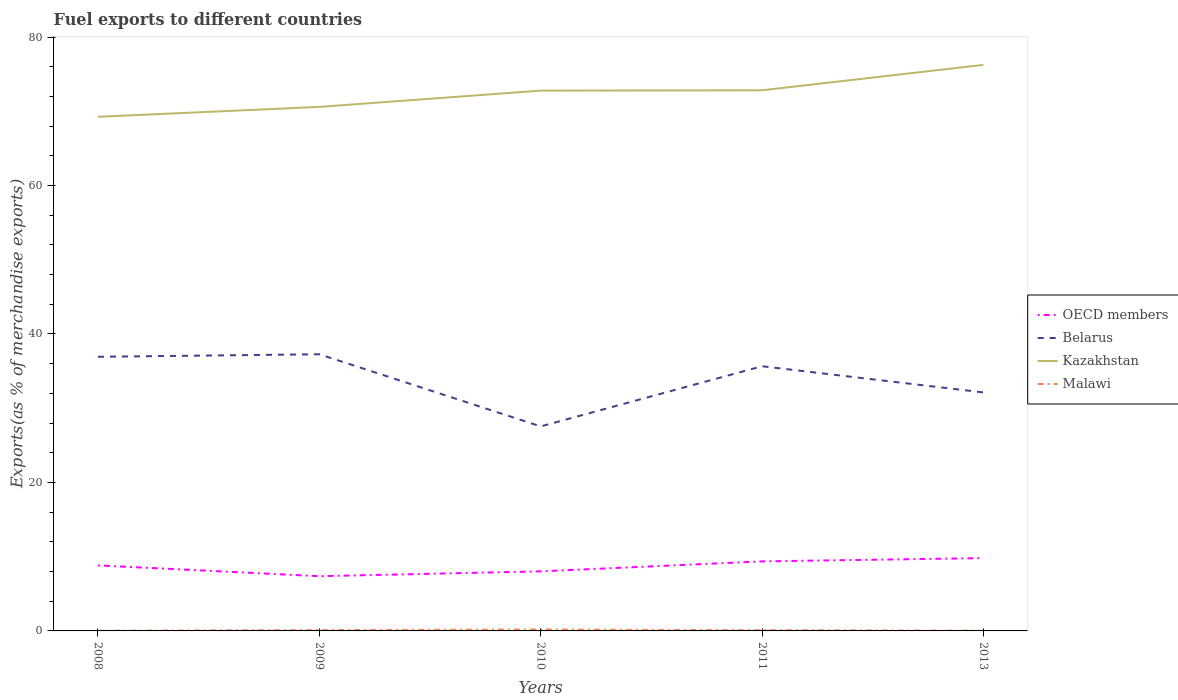How many different coloured lines are there?
Offer a very short reply. 4. Is the number of lines equal to the number of legend labels?
Provide a short and direct response. Yes. Across all years, what is the maximum percentage of exports to different countries in OECD members?
Your response must be concise. 7.37. What is the total percentage of exports to different countries in OECD members in the graph?
Your response must be concise. -1.99. What is the difference between the highest and the second highest percentage of exports to different countries in Belarus?
Provide a short and direct response. 9.72. What is the difference between the highest and the lowest percentage of exports to different countries in Malawi?
Ensure brevity in your answer.  3. How many lines are there?
Your answer should be very brief. 4. Are the values on the major ticks of Y-axis written in scientific E-notation?
Keep it short and to the point. No. Does the graph contain any zero values?
Offer a terse response. No. Where does the legend appear in the graph?
Your response must be concise. Center right. How many legend labels are there?
Provide a succinct answer. 4. What is the title of the graph?
Provide a short and direct response. Fuel exports to different countries. What is the label or title of the X-axis?
Offer a terse response. Years. What is the label or title of the Y-axis?
Provide a short and direct response. Exports(as % of merchandise exports). What is the Exports(as % of merchandise exports) of OECD members in 2008?
Give a very brief answer. 8.83. What is the Exports(as % of merchandise exports) in Belarus in 2008?
Your response must be concise. 36.93. What is the Exports(as % of merchandise exports) of Kazakhstan in 2008?
Your response must be concise. 69.25. What is the Exports(as % of merchandise exports) of Malawi in 2008?
Ensure brevity in your answer.  0.03. What is the Exports(as % of merchandise exports) in OECD members in 2009?
Your response must be concise. 7.37. What is the Exports(as % of merchandise exports) of Belarus in 2009?
Provide a succinct answer. 37.27. What is the Exports(as % of merchandise exports) in Kazakhstan in 2009?
Provide a succinct answer. 70.59. What is the Exports(as % of merchandise exports) of Malawi in 2009?
Keep it short and to the point. 0.11. What is the Exports(as % of merchandise exports) of OECD members in 2010?
Make the answer very short. 8.02. What is the Exports(as % of merchandise exports) of Belarus in 2010?
Offer a very short reply. 27.55. What is the Exports(as % of merchandise exports) of Kazakhstan in 2010?
Give a very brief answer. 72.78. What is the Exports(as % of merchandise exports) of Malawi in 2010?
Your answer should be compact. 0.19. What is the Exports(as % of merchandise exports) of OECD members in 2011?
Your answer should be compact. 9.37. What is the Exports(as % of merchandise exports) in Belarus in 2011?
Keep it short and to the point. 35.65. What is the Exports(as % of merchandise exports) of Kazakhstan in 2011?
Give a very brief answer. 72.83. What is the Exports(as % of merchandise exports) of Malawi in 2011?
Your answer should be very brief. 0.1. What is the Exports(as % of merchandise exports) of OECD members in 2013?
Keep it short and to the point. 9.81. What is the Exports(as % of merchandise exports) in Belarus in 2013?
Your response must be concise. 32.13. What is the Exports(as % of merchandise exports) of Kazakhstan in 2013?
Your answer should be very brief. 76.25. What is the Exports(as % of merchandise exports) in Malawi in 2013?
Keep it short and to the point. 0.04. Across all years, what is the maximum Exports(as % of merchandise exports) in OECD members?
Keep it short and to the point. 9.81. Across all years, what is the maximum Exports(as % of merchandise exports) in Belarus?
Your answer should be compact. 37.27. Across all years, what is the maximum Exports(as % of merchandise exports) of Kazakhstan?
Your answer should be very brief. 76.25. Across all years, what is the maximum Exports(as % of merchandise exports) of Malawi?
Offer a very short reply. 0.19. Across all years, what is the minimum Exports(as % of merchandise exports) of OECD members?
Your answer should be compact. 7.37. Across all years, what is the minimum Exports(as % of merchandise exports) of Belarus?
Your answer should be very brief. 27.55. Across all years, what is the minimum Exports(as % of merchandise exports) in Kazakhstan?
Provide a succinct answer. 69.25. Across all years, what is the minimum Exports(as % of merchandise exports) in Malawi?
Provide a short and direct response. 0.03. What is the total Exports(as % of merchandise exports) of OECD members in the graph?
Offer a terse response. 43.4. What is the total Exports(as % of merchandise exports) in Belarus in the graph?
Your response must be concise. 169.52. What is the total Exports(as % of merchandise exports) of Kazakhstan in the graph?
Your response must be concise. 361.69. What is the total Exports(as % of merchandise exports) in Malawi in the graph?
Keep it short and to the point. 0.46. What is the difference between the Exports(as % of merchandise exports) in OECD members in 2008 and that in 2009?
Offer a terse response. 1.46. What is the difference between the Exports(as % of merchandise exports) in Belarus in 2008 and that in 2009?
Your answer should be compact. -0.34. What is the difference between the Exports(as % of merchandise exports) in Kazakhstan in 2008 and that in 2009?
Your answer should be very brief. -1.33. What is the difference between the Exports(as % of merchandise exports) in Malawi in 2008 and that in 2009?
Offer a terse response. -0.09. What is the difference between the Exports(as % of merchandise exports) of OECD members in 2008 and that in 2010?
Give a very brief answer. 0.8. What is the difference between the Exports(as % of merchandise exports) of Belarus in 2008 and that in 2010?
Offer a very short reply. 9.38. What is the difference between the Exports(as % of merchandise exports) in Kazakhstan in 2008 and that in 2010?
Your response must be concise. -3.52. What is the difference between the Exports(as % of merchandise exports) in Malawi in 2008 and that in 2010?
Offer a very short reply. -0.16. What is the difference between the Exports(as % of merchandise exports) of OECD members in 2008 and that in 2011?
Provide a short and direct response. -0.54. What is the difference between the Exports(as % of merchandise exports) in Belarus in 2008 and that in 2011?
Offer a terse response. 1.27. What is the difference between the Exports(as % of merchandise exports) in Kazakhstan in 2008 and that in 2011?
Make the answer very short. -3.57. What is the difference between the Exports(as % of merchandise exports) of Malawi in 2008 and that in 2011?
Your answer should be compact. -0.07. What is the difference between the Exports(as % of merchandise exports) of OECD members in 2008 and that in 2013?
Offer a very short reply. -0.98. What is the difference between the Exports(as % of merchandise exports) in Belarus in 2008 and that in 2013?
Provide a succinct answer. 4.8. What is the difference between the Exports(as % of merchandise exports) in Kazakhstan in 2008 and that in 2013?
Make the answer very short. -6.99. What is the difference between the Exports(as % of merchandise exports) of Malawi in 2008 and that in 2013?
Offer a very short reply. -0.01. What is the difference between the Exports(as % of merchandise exports) of OECD members in 2009 and that in 2010?
Your answer should be very brief. -0.65. What is the difference between the Exports(as % of merchandise exports) of Belarus in 2009 and that in 2010?
Keep it short and to the point. 9.72. What is the difference between the Exports(as % of merchandise exports) in Kazakhstan in 2009 and that in 2010?
Your response must be concise. -2.19. What is the difference between the Exports(as % of merchandise exports) in Malawi in 2009 and that in 2010?
Ensure brevity in your answer.  -0.07. What is the difference between the Exports(as % of merchandise exports) of OECD members in 2009 and that in 2011?
Ensure brevity in your answer.  -1.99. What is the difference between the Exports(as % of merchandise exports) in Belarus in 2009 and that in 2011?
Offer a terse response. 1.61. What is the difference between the Exports(as % of merchandise exports) in Kazakhstan in 2009 and that in 2011?
Provide a succinct answer. -2.24. What is the difference between the Exports(as % of merchandise exports) in Malawi in 2009 and that in 2011?
Your answer should be very brief. 0.02. What is the difference between the Exports(as % of merchandise exports) of OECD members in 2009 and that in 2013?
Provide a succinct answer. -2.44. What is the difference between the Exports(as % of merchandise exports) in Belarus in 2009 and that in 2013?
Offer a very short reply. 5.14. What is the difference between the Exports(as % of merchandise exports) in Kazakhstan in 2009 and that in 2013?
Keep it short and to the point. -5.66. What is the difference between the Exports(as % of merchandise exports) in Malawi in 2009 and that in 2013?
Provide a succinct answer. 0.08. What is the difference between the Exports(as % of merchandise exports) in OECD members in 2010 and that in 2011?
Provide a short and direct response. -1.34. What is the difference between the Exports(as % of merchandise exports) in Belarus in 2010 and that in 2011?
Offer a very short reply. -8.1. What is the difference between the Exports(as % of merchandise exports) in Kazakhstan in 2010 and that in 2011?
Give a very brief answer. -0.05. What is the difference between the Exports(as % of merchandise exports) of Malawi in 2010 and that in 2011?
Offer a terse response. 0.09. What is the difference between the Exports(as % of merchandise exports) of OECD members in 2010 and that in 2013?
Offer a very short reply. -1.78. What is the difference between the Exports(as % of merchandise exports) in Belarus in 2010 and that in 2013?
Keep it short and to the point. -4.58. What is the difference between the Exports(as % of merchandise exports) of Kazakhstan in 2010 and that in 2013?
Provide a succinct answer. -3.47. What is the difference between the Exports(as % of merchandise exports) in Malawi in 2010 and that in 2013?
Give a very brief answer. 0.15. What is the difference between the Exports(as % of merchandise exports) in OECD members in 2011 and that in 2013?
Keep it short and to the point. -0.44. What is the difference between the Exports(as % of merchandise exports) of Belarus in 2011 and that in 2013?
Give a very brief answer. 3.53. What is the difference between the Exports(as % of merchandise exports) of Kazakhstan in 2011 and that in 2013?
Offer a terse response. -3.42. What is the difference between the Exports(as % of merchandise exports) in Malawi in 2011 and that in 2013?
Keep it short and to the point. 0.06. What is the difference between the Exports(as % of merchandise exports) of OECD members in 2008 and the Exports(as % of merchandise exports) of Belarus in 2009?
Offer a terse response. -28.44. What is the difference between the Exports(as % of merchandise exports) in OECD members in 2008 and the Exports(as % of merchandise exports) in Kazakhstan in 2009?
Make the answer very short. -61.76. What is the difference between the Exports(as % of merchandise exports) of OECD members in 2008 and the Exports(as % of merchandise exports) of Malawi in 2009?
Make the answer very short. 8.71. What is the difference between the Exports(as % of merchandise exports) of Belarus in 2008 and the Exports(as % of merchandise exports) of Kazakhstan in 2009?
Your answer should be compact. -33.66. What is the difference between the Exports(as % of merchandise exports) of Belarus in 2008 and the Exports(as % of merchandise exports) of Malawi in 2009?
Offer a terse response. 36.81. What is the difference between the Exports(as % of merchandise exports) of Kazakhstan in 2008 and the Exports(as % of merchandise exports) of Malawi in 2009?
Provide a short and direct response. 69.14. What is the difference between the Exports(as % of merchandise exports) in OECD members in 2008 and the Exports(as % of merchandise exports) in Belarus in 2010?
Your answer should be very brief. -18.72. What is the difference between the Exports(as % of merchandise exports) in OECD members in 2008 and the Exports(as % of merchandise exports) in Kazakhstan in 2010?
Ensure brevity in your answer.  -63.95. What is the difference between the Exports(as % of merchandise exports) of OECD members in 2008 and the Exports(as % of merchandise exports) of Malawi in 2010?
Keep it short and to the point. 8.64. What is the difference between the Exports(as % of merchandise exports) of Belarus in 2008 and the Exports(as % of merchandise exports) of Kazakhstan in 2010?
Make the answer very short. -35.85. What is the difference between the Exports(as % of merchandise exports) of Belarus in 2008 and the Exports(as % of merchandise exports) of Malawi in 2010?
Offer a terse response. 36.74. What is the difference between the Exports(as % of merchandise exports) in Kazakhstan in 2008 and the Exports(as % of merchandise exports) in Malawi in 2010?
Your answer should be very brief. 69.07. What is the difference between the Exports(as % of merchandise exports) of OECD members in 2008 and the Exports(as % of merchandise exports) of Belarus in 2011?
Keep it short and to the point. -26.83. What is the difference between the Exports(as % of merchandise exports) of OECD members in 2008 and the Exports(as % of merchandise exports) of Kazakhstan in 2011?
Provide a short and direct response. -64. What is the difference between the Exports(as % of merchandise exports) in OECD members in 2008 and the Exports(as % of merchandise exports) in Malawi in 2011?
Ensure brevity in your answer.  8.73. What is the difference between the Exports(as % of merchandise exports) of Belarus in 2008 and the Exports(as % of merchandise exports) of Kazakhstan in 2011?
Your response must be concise. -35.9. What is the difference between the Exports(as % of merchandise exports) of Belarus in 2008 and the Exports(as % of merchandise exports) of Malawi in 2011?
Your response must be concise. 36.83. What is the difference between the Exports(as % of merchandise exports) of Kazakhstan in 2008 and the Exports(as % of merchandise exports) of Malawi in 2011?
Provide a short and direct response. 69.16. What is the difference between the Exports(as % of merchandise exports) in OECD members in 2008 and the Exports(as % of merchandise exports) in Belarus in 2013?
Offer a very short reply. -23.3. What is the difference between the Exports(as % of merchandise exports) in OECD members in 2008 and the Exports(as % of merchandise exports) in Kazakhstan in 2013?
Make the answer very short. -67.42. What is the difference between the Exports(as % of merchandise exports) in OECD members in 2008 and the Exports(as % of merchandise exports) in Malawi in 2013?
Give a very brief answer. 8.79. What is the difference between the Exports(as % of merchandise exports) of Belarus in 2008 and the Exports(as % of merchandise exports) of Kazakhstan in 2013?
Offer a terse response. -39.32. What is the difference between the Exports(as % of merchandise exports) in Belarus in 2008 and the Exports(as % of merchandise exports) in Malawi in 2013?
Provide a short and direct response. 36.89. What is the difference between the Exports(as % of merchandise exports) in Kazakhstan in 2008 and the Exports(as % of merchandise exports) in Malawi in 2013?
Provide a succinct answer. 69.22. What is the difference between the Exports(as % of merchandise exports) of OECD members in 2009 and the Exports(as % of merchandise exports) of Belarus in 2010?
Offer a terse response. -20.18. What is the difference between the Exports(as % of merchandise exports) of OECD members in 2009 and the Exports(as % of merchandise exports) of Kazakhstan in 2010?
Give a very brief answer. -65.41. What is the difference between the Exports(as % of merchandise exports) in OECD members in 2009 and the Exports(as % of merchandise exports) in Malawi in 2010?
Provide a short and direct response. 7.19. What is the difference between the Exports(as % of merchandise exports) in Belarus in 2009 and the Exports(as % of merchandise exports) in Kazakhstan in 2010?
Offer a terse response. -35.51. What is the difference between the Exports(as % of merchandise exports) of Belarus in 2009 and the Exports(as % of merchandise exports) of Malawi in 2010?
Keep it short and to the point. 37.08. What is the difference between the Exports(as % of merchandise exports) of Kazakhstan in 2009 and the Exports(as % of merchandise exports) of Malawi in 2010?
Provide a short and direct response. 70.4. What is the difference between the Exports(as % of merchandise exports) in OECD members in 2009 and the Exports(as % of merchandise exports) in Belarus in 2011?
Ensure brevity in your answer.  -28.28. What is the difference between the Exports(as % of merchandise exports) in OECD members in 2009 and the Exports(as % of merchandise exports) in Kazakhstan in 2011?
Provide a succinct answer. -65.45. What is the difference between the Exports(as % of merchandise exports) of OECD members in 2009 and the Exports(as % of merchandise exports) of Malawi in 2011?
Your answer should be compact. 7.27. What is the difference between the Exports(as % of merchandise exports) of Belarus in 2009 and the Exports(as % of merchandise exports) of Kazakhstan in 2011?
Your response must be concise. -35.56. What is the difference between the Exports(as % of merchandise exports) in Belarus in 2009 and the Exports(as % of merchandise exports) in Malawi in 2011?
Your answer should be very brief. 37.17. What is the difference between the Exports(as % of merchandise exports) of Kazakhstan in 2009 and the Exports(as % of merchandise exports) of Malawi in 2011?
Your response must be concise. 70.49. What is the difference between the Exports(as % of merchandise exports) of OECD members in 2009 and the Exports(as % of merchandise exports) of Belarus in 2013?
Provide a succinct answer. -24.75. What is the difference between the Exports(as % of merchandise exports) in OECD members in 2009 and the Exports(as % of merchandise exports) in Kazakhstan in 2013?
Provide a short and direct response. -68.88. What is the difference between the Exports(as % of merchandise exports) of OECD members in 2009 and the Exports(as % of merchandise exports) of Malawi in 2013?
Provide a short and direct response. 7.34. What is the difference between the Exports(as % of merchandise exports) in Belarus in 2009 and the Exports(as % of merchandise exports) in Kazakhstan in 2013?
Your answer should be very brief. -38.98. What is the difference between the Exports(as % of merchandise exports) of Belarus in 2009 and the Exports(as % of merchandise exports) of Malawi in 2013?
Provide a succinct answer. 37.23. What is the difference between the Exports(as % of merchandise exports) of Kazakhstan in 2009 and the Exports(as % of merchandise exports) of Malawi in 2013?
Your answer should be very brief. 70.55. What is the difference between the Exports(as % of merchandise exports) in OECD members in 2010 and the Exports(as % of merchandise exports) in Belarus in 2011?
Give a very brief answer. -27.63. What is the difference between the Exports(as % of merchandise exports) in OECD members in 2010 and the Exports(as % of merchandise exports) in Kazakhstan in 2011?
Give a very brief answer. -64.8. What is the difference between the Exports(as % of merchandise exports) of OECD members in 2010 and the Exports(as % of merchandise exports) of Malawi in 2011?
Provide a short and direct response. 7.93. What is the difference between the Exports(as % of merchandise exports) in Belarus in 2010 and the Exports(as % of merchandise exports) in Kazakhstan in 2011?
Your response must be concise. -45.28. What is the difference between the Exports(as % of merchandise exports) in Belarus in 2010 and the Exports(as % of merchandise exports) in Malawi in 2011?
Your response must be concise. 27.45. What is the difference between the Exports(as % of merchandise exports) of Kazakhstan in 2010 and the Exports(as % of merchandise exports) of Malawi in 2011?
Make the answer very short. 72.68. What is the difference between the Exports(as % of merchandise exports) of OECD members in 2010 and the Exports(as % of merchandise exports) of Belarus in 2013?
Your answer should be very brief. -24.1. What is the difference between the Exports(as % of merchandise exports) in OECD members in 2010 and the Exports(as % of merchandise exports) in Kazakhstan in 2013?
Provide a short and direct response. -68.22. What is the difference between the Exports(as % of merchandise exports) in OECD members in 2010 and the Exports(as % of merchandise exports) in Malawi in 2013?
Keep it short and to the point. 7.99. What is the difference between the Exports(as % of merchandise exports) in Belarus in 2010 and the Exports(as % of merchandise exports) in Kazakhstan in 2013?
Keep it short and to the point. -48.7. What is the difference between the Exports(as % of merchandise exports) in Belarus in 2010 and the Exports(as % of merchandise exports) in Malawi in 2013?
Your answer should be very brief. 27.51. What is the difference between the Exports(as % of merchandise exports) of Kazakhstan in 2010 and the Exports(as % of merchandise exports) of Malawi in 2013?
Your answer should be very brief. 72.74. What is the difference between the Exports(as % of merchandise exports) in OECD members in 2011 and the Exports(as % of merchandise exports) in Belarus in 2013?
Your answer should be compact. -22.76. What is the difference between the Exports(as % of merchandise exports) of OECD members in 2011 and the Exports(as % of merchandise exports) of Kazakhstan in 2013?
Your answer should be compact. -66.88. What is the difference between the Exports(as % of merchandise exports) of OECD members in 2011 and the Exports(as % of merchandise exports) of Malawi in 2013?
Your response must be concise. 9.33. What is the difference between the Exports(as % of merchandise exports) in Belarus in 2011 and the Exports(as % of merchandise exports) in Kazakhstan in 2013?
Offer a very short reply. -40.59. What is the difference between the Exports(as % of merchandise exports) of Belarus in 2011 and the Exports(as % of merchandise exports) of Malawi in 2013?
Provide a succinct answer. 35.62. What is the difference between the Exports(as % of merchandise exports) of Kazakhstan in 2011 and the Exports(as % of merchandise exports) of Malawi in 2013?
Provide a succinct answer. 72.79. What is the average Exports(as % of merchandise exports) of OECD members per year?
Provide a short and direct response. 8.68. What is the average Exports(as % of merchandise exports) in Belarus per year?
Provide a succinct answer. 33.9. What is the average Exports(as % of merchandise exports) in Kazakhstan per year?
Give a very brief answer. 72.34. What is the average Exports(as % of merchandise exports) of Malawi per year?
Ensure brevity in your answer.  0.09. In the year 2008, what is the difference between the Exports(as % of merchandise exports) in OECD members and Exports(as % of merchandise exports) in Belarus?
Offer a terse response. -28.1. In the year 2008, what is the difference between the Exports(as % of merchandise exports) in OECD members and Exports(as % of merchandise exports) in Kazakhstan?
Ensure brevity in your answer.  -60.43. In the year 2008, what is the difference between the Exports(as % of merchandise exports) in OECD members and Exports(as % of merchandise exports) in Malawi?
Make the answer very short. 8.8. In the year 2008, what is the difference between the Exports(as % of merchandise exports) of Belarus and Exports(as % of merchandise exports) of Kazakhstan?
Keep it short and to the point. -32.33. In the year 2008, what is the difference between the Exports(as % of merchandise exports) of Belarus and Exports(as % of merchandise exports) of Malawi?
Provide a short and direct response. 36.9. In the year 2008, what is the difference between the Exports(as % of merchandise exports) of Kazakhstan and Exports(as % of merchandise exports) of Malawi?
Your response must be concise. 69.23. In the year 2009, what is the difference between the Exports(as % of merchandise exports) of OECD members and Exports(as % of merchandise exports) of Belarus?
Provide a succinct answer. -29.89. In the year 2009, what is the difference between the Exports(as % of merchandise exports) of OECD members and Exports(as % of merchandise exports) of Kazakhstan?
Ensure brevity in your answer.  -63.21. In the year 2009, what is the difference between the Exports(as % of merchandise exports) of OECD members and Exports(as % of merchandise exports) of Malawi?
Ensure brevity in your answer.  7.26. In the year 2009, what is the difference between the Exports(as % of merchandise exports) in Belarus and Exports(as % of merchandise exports) in Kazakhstan?
Give a very brief answer. -33.32. In the year 2009, what is the difference between the Exports(as % of merchandise exports) of Belarus and Exports(as % of merchandise exports) of Malawi?
Keep it short and to the point. 37.15. In the year 2009, what is the difference between the Exports(as % of merchandise exports) in Kazakhstan and Exports(as % of merchandise exports) in Malawi?
Provide a short and direct response. 70.47. In the year 2010, what is the difference between the Exports(as % of merchandise exports) in OECD members and Exports(as % of merchandise exports) in Belarus?
Ensure brevity in your answer.  -19.52. In the year 2010, what is the difference between the Exports(as % of merchandise exports) of OECD members and Exports(as % of merchandise exports) of Kazakhstan?
Ensure brevity in your answer.  -64.75. In the year 2010, what is the difference between the Exports(as % of merchandise exports) of OECD members and Exports(as % of merchandise exports) of Malawi?
Ensure brevity in your answer.  7.84. In the year 2010, what is the difference between the Exports(as % of merchandise exports) in Belarus and Exports(as % of merchandise exports) in Kazakhstan?
Provide a short and direct response. -45.23. In the year 2010, what is the difference between the Exports(as % of merchandise exports) in Belarus and Exports(as % of merchandise exports) in Malawi?
Offer a terse response. 27.36. In the year 2010, what is the difference between the Exports(as % of merchandise exports) in Kazakhstan and Exports(as % of merchandise exports) in Malawi?
Provide a short and direct response. 72.59. In the year 2011, what is the difference between the Exports(as % of merchandise exports) of OECD members and Exports(as % of merchandise exports) of Belarus?
Make the answer very short. -26.29. In the year 2011, what is the difference between the Exports(as % of merchandise exports) in OECD members and Exports(as % of merchandise exports) in Kazakhstan?
Give a very brief answer. -63.46. In the year 2011, what is the difference between the Exports(as % of merchandise exports) of OECD members and Exports(as % of merchandise exports) of Malawi?
Provide a succinct answer. 9.27. In the year 2011, what is the difference between the Exports(as % of merchandise exports) of Belarus and Exports(as % of merchandise exports) of Kazakhstan?
Make the answer very short. -37.17. In the year 2011, what is the difference between the Exports(as % of merchandise exports) in Belarus and Exports(as % of merchandise exports) in Malawi?
Provide a succinct answer. 35.56. In the year 2011, what is the difference between the Exports(as % of merchandise exports) of Kazakhstan and Exports(as % of merchandise exports) of Malawi?
Provide a succinct answer. 72.73. In the year 2013, what is the difference between the Exports(as % of merchandise exports) of OECD members and Exports(as % of merchandise exports) of Belarus?
Offer a very short reply. -22.32. In the year 2013, what is the difference between the Exports(as % of merchandise exports) in OECD members and Exports(as % of merchandise exports) in Kazakhstan?
Give a very brief answer. -66.44. In the year 2013, what is the difference between the Exports(as % of merchandise exports) of OECD members and Exports(as % of merchandise exports) of Malawi?
Keep it short and to the point. 9.77. In the year 2013, what is the difference between the Exports(as % of merchandise exports) of Belarus and Exports(as % of merchandise exports) of Kazakhstan?
Give a very brief answer. -44.12. In the year 2013, what is the difference between the Exports(as % of merchandise exports) of Belarus and Exports(as % of merchandise exports) of Malawi?
Ensure brevity in your answer.  32.09. In the year 2013, what is the difference between the Exports(as % of merchandise exports) of Kazakhstan and Exports(as % of merchandise exports) of Malawi?
Offer a very short reply. 76.21. What is the ratio of the Exports(as % of merchandise exports) of OECD members in 2008 to that in 2009?
Provide a succinct answer. 1.2. What is the ratio of the Exports(as % of merchandise exports) in Belarus in 2008 to that in 2009?
Your answer should be very brief. 0.99. What is the ratio of the Exports(as % of merchandise exports) of Kazakhstan in 2008 to that in 2009?
Provide a short and direct response. 0.98. What is the ratio of the Exports(as % of merchandise exports) of Malawi in 2008 to that in 2009?
Ensure brevity in your answer.  0.24. What is the ratio of the Exports(as % of merchandise exports) of Belarus in 2008 to that in 2010?
Offer a terse response. 1.34. What is the ratio of the Exports(as % of merchandise exports) in Kazakhstan in 2008 to that in 2010?
Your response must be concise. 0.95. What is the ratio of the Exports(as % of merchandise exports) in Malawi in 2008 to that in 2010?
Your answer should be very brief. 0.15. What is the ratio of the Exports(as % of merchandise exports) in OECD members in 2008 to that in 2011?
Keep it short and to the point. 0.94. What is the ratio of the Exports(as % of merchandise exports) of Belarus in 2008 to that in 2011?
Your response must be concise. 1.04. What is the ratio of the Exports(as % of merchandise exports) in Kazakhstan in 2008 to that in 2011?
Offer a terse response. 0.95. What is the ratio of the Exports(as % of merchandise exports) in Malawi in 2008 to that in 2011?
Your answer should be compact. 0.27. What is the ratio of the Exports(as % of merchandise exports) of OECD members in 2008 to that in 2013?
Offer a terse response. 0.9. What is the ratio of the Exports(as % of merchandise exports) of Belarus in 2008 to that in 2013?
Offer a terse response. 1.15. What is the ratio of the Exports(as % of merchandise exports) of Kazakhstan in 2008 to that in 2013?
Offer a terse response. 0.91. What is the ratio of the Exports(as % of merchandise exports) in Malawi in 2008 to that in 2013?
Offer a very short reply. 0.74. What is the ratio of the Exports(as % of merchandise exports) in OECD members in 2009 to that in 2010?
Your response must be concise. 0.92. What is the ratio of the Exports(as % of merchandise exports) in Belarus in 2009 to that in 2010?
Your response must be concise. 1.35. What is the ratio of the Exports(as % of merchandise exports) of Kazakhstan in 2009 to that in 2010?
Your response must be concise. 0.97. What is the ratio of the Exports(as % of merchandise exports) of Malawi in 2009 to that in 2010?
Ensure brevity in your answer.  0.61. What is the ratio of the Exports(as % of merchandise exports) of OECD members in 2009 to that in 2011?
Offer a terse response. 0.79. What is the ratio of the Exports(as % of merchandise exports) in Belarus in 2009 to that in 2011?
Give a very brief answer. 1.05. What is the ratio of the Exports(as % of merchandise exports) in Kazakhstan in 2009 to that in 2011?
Give a very brief answer. 0.97. What is the ratio of the Exports(as % of merchandise exports) of Malawi in 2009 to that in 2011?
Offer a terse response. 1.15. What is the ratio of the Exports(as % of merchandise exports) of OECD members in 2009 to that in 2013?
Offer a very short reply. 0.75. What is the ratio of the Exports(as % of merchandise exports) in Belarus in 2009 to that in 2013?
Give a very brief answer. 1.16. What is the ratio of the Exports(as % of merchandise exports) of Kazakhstan in 2009 to that in 2013?
Your answer should be compact. 0.93. What is the ratio of the Exports(as % of merchandise exports) of Malawi in 2009 to that in 2013?
Give a very brief answer. 3.11. What is the ratio of the Exports(as % of merchandise exports) of OECD members in 2010 to that in 2011?
Provide a succinct answer. 0.86. What is the ratio of the Exports(as % of merchandise exports) in Belarus in 2010 to that in 2011?
Make the answer very short. 0.77. What is the ratio of the Exports(as % of merchandise exports) in Kazakhstan in 2010 to that in 2011?
Your answer should be very brief. 1. What is the ratio of the Exports(as % of merchandise exports) of Malawi in 2010 to that in 2011?
Ensure brevity in your answer.  1.88. What is the ratio of the Exports(as % of merchandise exports) in OECD members in 2010 to that in 2013?
Your response must be concise. 0.82. What is the ratio of the Exports(as % of merchandise exports) in Belarus in 2010 to that in 2013?
Provide a succinct answer. 0.86. What is the ratio of the Exports(as % of merchandise exports) of Kazakhstan in 2010 to that in 2013?
Keep it short and to the point. 0.95. What is the ratio of the Exports(as % of merchandise exports) of Malawi in 2010 to that in 2013?
Keep it short and to the point. 5.08. What is the ratio of the Exports(as % of merchandise exports) in OECD members in 2011 to that in 2013?
Ensure brevity in your answer.  0.96. What is the ratio of the Exports(as % of merchandise exports) in Belarus in 2011 to that in 2013?
Make the answer very short. 1.11. What is the ratio of the Exports(as % of merchandise exports) in Kazakhstan in 2011 to that in 2013?
Provide a succinct answer. 0.96. What is the ratio of the Exports(as % of merchandise exports) of Malawi in 2011 to that in 2013?
Provide a succinct answer. 2.7. What is the difference between the highest and the second highest Exports(as % of merchandise exports) of OECD members?
Keep it short and to the point. 0.44. What is the difference between the highest and the second highest Exports(as % of merchandise exports) of Belarus?
Make the answer very short. 0.34. What is the difference between the highest and the second highest Exports(as % of merchandise exports) in Kazakhstan?
Make the answer very short. 3.42. What is the difference between the highest and the second highest Exports(as % of merchandise exports) of Malawi?
Your answer should be very brief. 0.07. What is the difference between the highest and the lowest Exports(as % of merchandise exports) in OECD members?
Offer a very short reply. 2.44. What is the difference between the highest and the lowest Exports(as % of merchandise exports) of Belarus?
Provide a short and direct response. 9.72. What is the difference between the highest and the lowest Exports(as % of merchandise exports) of Kazakhstan?
Provide a short and direct response. 6.99. What is the difference between the highest and the lowest Exports(as % of merchandise exports) in Malawi?
Offer a very short reply. 0.16. 